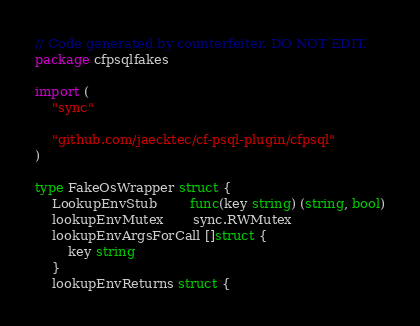Convert code to text. <code><loc_0><loc_0><loc_500><loc_500><_Go_>// Code generated by counterfeiter. DO NOT EDIT.
package cfpsqlfakes

import (
	"sync"

	"github.com/jaecktec/cf-psql-plugin/cfpsql"
)

type FakeOsWrapper struct {
	LookupEnvStub        func(key string) (string, bool)
	lookupEnvMutex       sync.RWMutex
	lookupEnvArgsForCall []struct {
		key string
	}
	lookupEnvReturns struct {</code> 